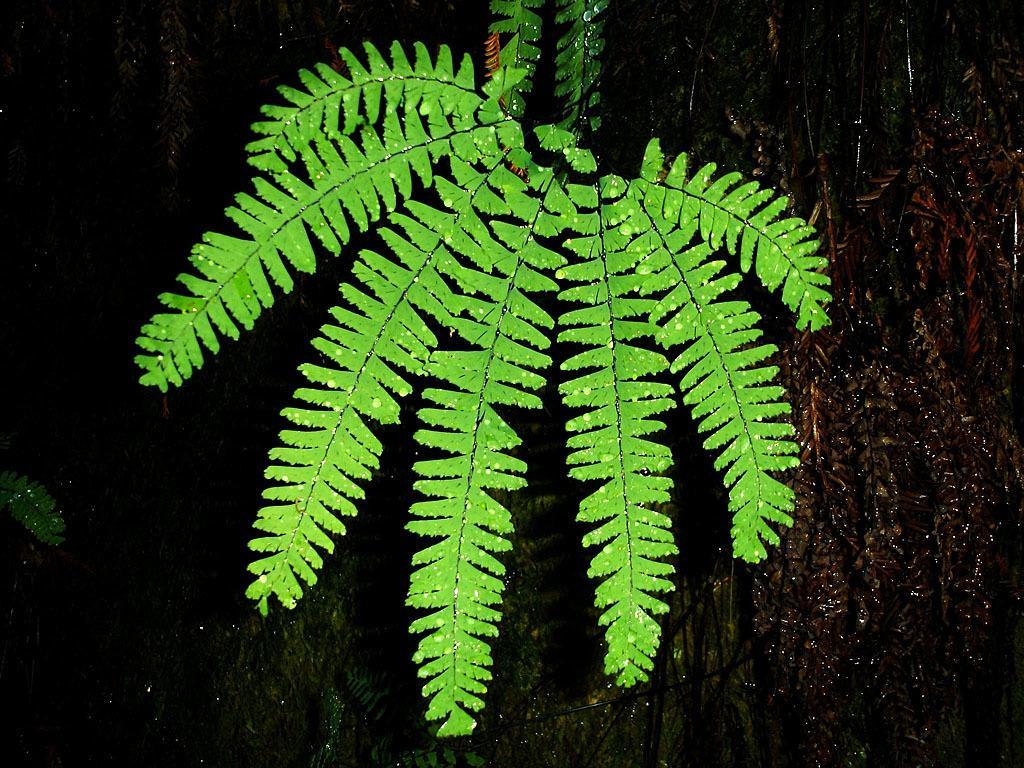Describe this image in one or two sentences. In this picture we can see leaves, trees and dark background. 